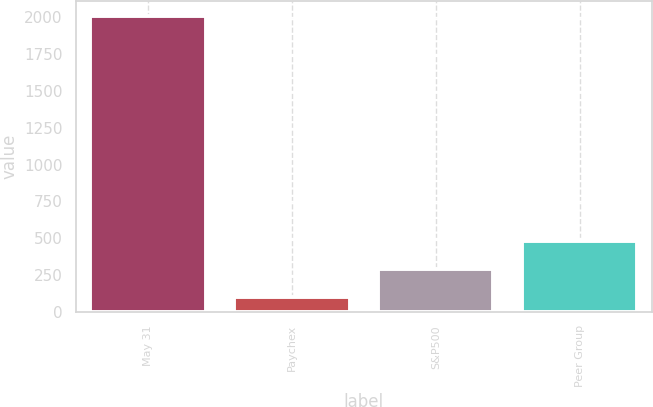<chart> <loc_0><loc_0><loc_500><loc_500><bar_chart><fcel>May 31<fcel>Paychex<fcel>S&P500<fcel>Peer Group<nl><fcel>2013<fcel>100<fcel>291.3<fcel>482.6<nl></chart> 